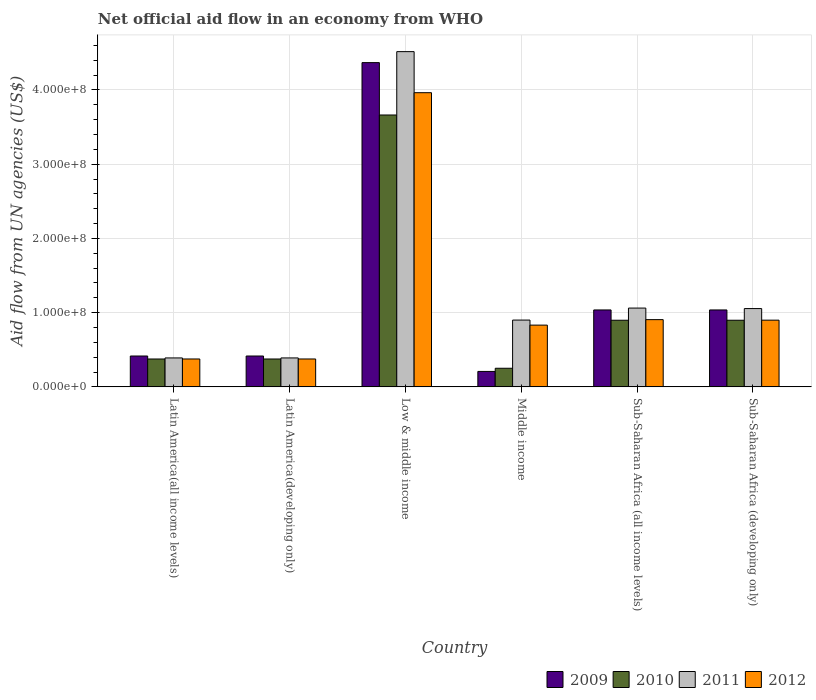Are the number of bars on each tick of the X-axis equal?
Offer a very short reply. Yes. How many bars are there on the 1st tick from the right?
Your answer should be very brief. 4. What is the label of the 1st group of bars from the left?
Ensure brevity in your answer.  Latin America(all income levels). In how many cases, is the number of bars for a given country not equal to the number of legend labels?
Give a very brief answer. 0. What is the net official aid flow in 2009 in Sub-Saharan Africa (developing only)?
Your answer should be very brief. 1.04e+08. Across all countries, what is the maximum net official aid flow in 2011?
Your answer should be compact. 4.52e+08. Across all countries, what is the minimum net official aid flow in 2010?
Keep it short and to the point. 2.51e+07. In which country was the net official aid flow in 2010 maximum?
Provide a succinct answer. Low & middle income. What is the total net official aid flow in 2011 in the graph?
Your response must be concise. 8.31e+08. What is the difference between the net official aid flow in 2012 in Latin America(developing only) and that in Middle income?
Keep it short and to the point. -4.56e+07. What is the difference between the net official aid flow in 2011 in Low & middle income and the net official aid flow in 2009 in Middle income?
Keep it short and to the point. 4.31e+08. What is the average net official aid flow in 2009 per country?
Provide a short and direct response. 1.25e+08. What is the difference between the net official aid flow of/in 2009 and net official aid flow of/in 2012 in Middle income?
Make the answer very short. -6.24e+07. In how many countries, is the net official aid flow in 2011 greater than 340000000 US$?
Offer a very short reply. 1. What is the ratio of the net official aid flow in 2009 in Sub-Saharan Africa (all income levels) to that in Sub-Saharan Africa (developing only)?
Offer a very short reply. 1. Is the net official aid flow in 2009 in Latin America(developing only) less than that in Middle income?
Make the answer very short. No. What is the difference between the highest and the second highest net official aid flow in 2012?
Your response must be concise. 3.06e+08. What is the difference between the highest and the lowest net official aid flow in 2010?
Your answer should be compact. 3.41e+08. Is it the case that in every country, the sum of the net official aid flow in 2011 and net official aid flow in 2012 is greater than the sum of net official aid flow in 2010 and net official aid flow in 2009?
Your answer should be very brief. No. What does the 3rd bar from the right in Low & middle income represents?
Offer a very short reply. 2010. Is it the case that in every country, the sum of the net official aid flow in 2009 and net official aid flow in 2010 is greater than the net official aid flow in 2012?
Offer a very short reply. No. How many countries are there in the graph?
Give a very brief answer. 6. Does the graph contain any zero values?
Your response must be concise. No. Does the graph contain grids?
Offer a very short reply. Yes. How many legend labels are there?
Your answer should be very brief. 4. What is the title of the graph?
Keep it short and to the point. Net official aid flow in an economy from WHO. What is the label or title of the Y-axis?
Your answer should be very brief. Aid flow from UN agencies (US$). What is the Aid flow from UN agencies (US$) in 2009 in Latin America(all income levels)?
Keep it short and to the point. 4.16e+07. What is the Aid flow from UN agencies (US$) in 2010 in Latin America(all income levels)?
Provide a succinct answer. 3.76e+07. What is the Aid flow from UN agencies (US$) in 2011 in Latin America(all income levels)?
Make the answer very short. 3.90e+07. What is the Aid flow from UN agencies (US$) in 2012 in Latin America(all income levels)?
Your answer should be compact. 3.76e+07. What is the Aid flow from UN agencies (US$) in 2009 in Latin America(developing only)?
Keep it short and to the point. 4.16e+07. What is the Aid flow from UN agencies (US$) in 2010 in Latin America(developing only)?
Your response must be concise. 3.76e+07. What is the Aid flow from UN agencies (US$) in 2011 in Latin America(developing only)?
Provide a succinct answer. 3.90e+07. What is the Aid flow from UN agencies (US$) of 2012 in Latin America(developing only)?
Your response must be concise. 3.76e+07. What is the Aid flow from UN agencies (US$) of 2009 in Low & middle income?
Your answer should be very brief. 4.37e+08. What is the Aid flow from UN agencies (US$) of 2010 in Low & middle income?
Offer a terse response. 3.66e+08. What is the Aid flow from UN agencies (US$) of 2011 in Low & middle income?
Give a very brief answer. 4.52e+08. What is the Aid flow from UN agencies (US$) in 2012 in Low & middle income?
Offer a very short reply. 3.96e+08. What is the Aid flow from UN agencies (US$) of 2009 in Middle income?
Ensure brevity in your answer.  2.08e+07. What is the Aid flow from UN agencies (US$) in 2010 in Middle income?
Keep it short and to the point. 2.51e+07. What is the Aid flow from UN agencies (US$) of 2011 in Middle income?
Your response must be concise. 9.00e+07. What is the Aid flow from UN agencies (US$) of 2012 in Middle income?
Offer a terse response. 8.32e+07. What is the Aid flow from UN agencies (US$) in 2009 in Sub-Saharan Africa (all income levels)?
Give a very brief answer. 1.04e+08. What is the Aid flow from UN agencies (US$) in 2010 in Sub-Saharan Africa (all income levels)?
Your answer should be very brief. 8.98e+07. What is the Aid flow from UN agencies (US$) of 2011 in Sub-Saharan Africa (all income levels)?
Make the answer very short. 1.06e+08. What is the Aid flow from UN agencies (US$) in 2012 in Sub-Saharan Africa (all income levels)?
Make the answer very short. 9.06e+07. What is the Aid flow from UN agencies (US$) of 2009 in Sub-Saharan Africa (developing only)?
Give a very brief answer. 1.04e+08. What is the Aid flow from UN agencies (US$) of 2010 in Sub-Saharan Africa (developing only)?
Your answer should be very brief. 8.98e+07. What is the Aid flow from UN agencies (US$) of 2011 in Sub-Saharan Africa (developing only)?
Provide a short and direct response. 1.05e+08. What is the Aid flow from UN agencies (US$) of 2012 in Sub-Saharan Africa (developing only)?
Provide a succinct answer. 8.98e+07. Across all countries, what is the maximum Aid flow from UN agencies (US$) of 2009?
Ensure brevity in your answer.  4.37e+08. Across all countries, what is the maximum Aid flow from UN agencies (US$) of 2010?
Give a very brief answer. 3.66e+08. Across all countries, what is the maximum Aid flow from UN agencies (US$) of 2011?
Make the answer very short. 4.52e+08. Across all countries, what is the maximum Aid flow from UN agencies (US$) in 2012?
Give a very brief answer. 3.96e+08. Across all countries, what is the minimum Aid flow from UN agencies (US$) in 2009?
Your answer should be very brief. 2.08e+07. Across all countries, what is the minimum Aid flow from UN agencies (US$) in 2010?
Give a very brief answer. 2.51e+07. Across all countries, what is the minimum Aid flow from UN agencies (US$) of 2011?
Give a very brief answer. 3.90e+07. Across all countries, what is the minimum Aid flow from UN agencies (US$) of 2012?
Keep it short and to the point. 3.76e+07. What is the total Aid flow from UN agencies (US$) of 2009 in the graph?
Make the answer very short. 7.48e+08. What is the total Aid flow from UN agencies (US$) of 2010 in the graph?
Give a very brief answer. 6.46e+08. What is the total Aid flow from UN agencies (US$) in 2011 in the graph?
Provide a short and direct response. 8.31e+08. What is the total Aid flow from UN agencies (US$) in 2012 in the graph?
Keep it short and to the point. 7.35e+08. What is the difference between the Aid flow from UN agencies (US$) in 2009 in Latin America(all income levels) and that in Latin America(developing only)?
Provide a succinct answer. 0. What is the difference between the Aid flow from UN agencies (US$) in 2010 in Latin America(all income levels) and that in Latin America(developing only)?
Your answer should be compact. 0. What is the difference between the Aid flow from UN agencies (US$) in 2011 in Latin America(all income levels) and that in Latin America(developing only)?
Your answer should be compact. 0. What is the difference between the Aid flow from UN agencies (US$) in 2009 in Latin America(all income levels) and that in Low & middle income?
Your answer should be very brief. -3.95e+08. What is the difference between the Aid flow from UN agencies (US$) in 2010 in Latin America(all income levels) and that in Low & middle income?
Your response must be concise. -3.29e+08. What is the difference between the Aid flow from UN agencies (US$) in 2011 in Latin America(all income levels) and that in Low & middle income?
Provide a short and direct response. -4.13e+08. What is the difference between the Aid flow from UN agencies (US$) of 2012 in Latin America(all income levels) and that in Low & middle income?
Your answer should be compact. -3.59e+08. What is the difference between the Aid flow from UN agencies (US$) in 2009 in Latin America(all income levels) and that in Middle income?
Your answer should be very brief. 2.08e+07. What is the difference between the Aid flow from UN agencies (US$) of 2010 in Latin America(all income levels) and that in Middle income?
Your answer should be very brief. 1.25e+07. What is the difference between the Aid flow from UN agencies (US$) of 2011 in Latin America(all income levels) and that in Middle income?
Offer a terse response. -5.10e+07. What is the difference between the Aid flow from UN agencies (US$) of 2012 in Latin America(all income levels) and that in Middle income?
Ensure brevity in your answer.  -4.56e+07. What is the difference between the Aid flow from UN agencies (US$) of 2009 in Latin America(all income levels) and that in Sub-Saharan Africa (all income levels)?
Offer a terse response. -6.20e+07. What is the difference between the Aid flow from UN agencies (US$) in 2010 in Latin America(all income levels) and that in Sub-Saharan Africa (all income levels)?
Provide a short and direct response. -5.22e+07. What is the difference between the Aid flow from UN agencies (US$) in 2011 in Latin America(all income levels) and that in Sub-Saharan Africa (all income levels)?
Provide a succinct answer. -6.72e+07. What is the difference between the Aid flow from UN agencies (US$) of 2012 in Latin America(all income levels) and that in Sub-Saharan Africa (all income levels)?
Offer a very short reply. -5.30e+07. What is the difference between the Aid flow from UN agencies (US$) in 2009 in Latin America(all income levels) and that in Sub-Saharan Africa (developing only)?
Your answer should be compact. -6.20e+07. What is the difference between the Aid flow from UN agencies (US$) of 2010 in Latin America(all income levels) and that in Sub-Saharan Africa (developing only)?
Give a very brief answer. -5.22e+07. What is the difference between the Aid flow from UN agencies (US$) in 2011 in Latin America(all income levels) and that in Sub-Saharan Africa (developing only)?
Offer a very short reply. -6.65e+07. What is the difference between the Aid flow from UN agencies (US$) of 2012 in Latin America(all income levels) and that in Sub-Saharan Africa (developing only)?
Provide a short and direct response. -5.23e+07. What is the difference between the Aid flow from UN agencies (US$) of 2009 in Latin America(developing only) and that in Low & middle income?
Provide a short and direct response. -3.95e+08. What is the difference between the Aid flow from UN agencies (US$) of 2010 in Latin America(developing only) and that in Low & middle income?
Offer a terse response. -3.29e+08. What is the difference between the Aid flow from UN agencies (US$) of 2011 in Latin America(developing only) and that in Low & middle income?
Give a very brief answer. -4.13e+08. What is the difference between the Aid flow from UN agencies (US$) in 2012 in Latin America(developing only) and that in Low & middle income?
Your answer should be very brief. -3.59e+08. What is the difference between the Aid flow from UN agencies (US$) of 2009 in Latin America(developing only) and that in Middle income?
Keep it short and to the point. 2.08e+07. What is the difference between the Aid flow from UN agencies (US$) in 2010 in Latin America(developing only) and that in Middle income?
Ensure brevity in your answer.  1.25e+07. What is the difference between the Aid flow from UN agencies (US$) in 2011 in Latin America(developing only) and that in Middle income?
Provide a short and direct response. -5.10e+07. What is the difference between the Aid flow from UN agencies (US$) in 2012 in Latin America(developing only) and that in Middle income?
Your answer should be very brief. -4.56e+07. What is the difference between the Aid flow from UN agencies (US$) of 2009 in Latin America(developing only) and that in Sub-Saharan Africa (all income levels)?
Offer a terse response. -6.20e+07. What is the difference between the Aid flow from UN agencies (US$) in 2010 in Latin America(developing only) and that in Sub-Saharan Africa (all income levels)?
Keep it short and to the point. -5.22e+07. What is the difference between the Aid flow from UN agencies (US$) of 2011 in Latin America(developing only) and that in Sub-Saharan Africa (all income levels)?
Give a very brief answer. -6.72e+07. What is the difference between the Aid flow from UN agencies (US$) of 2012 in Latin America(developing only) and that in Sub-Saharan Africa (all income levels)?
Your response must be concise. -5.30e+07. What is the difference between the Aid flow from UN agencies (US$) in 2009 in Latin America(developing only) and that in Sub-Saharan Africa (developing only)?
Provide a succinct answer. -6.20e+07. What is the difference between the Aid flow from UN agencies (US$) in 2010 in Latin America(developing only) and that in Sub-Saharan Africa (developing only)?
Keep it short and to the point. -5.22e+07. What is the difference between the Aid flow from UN agencies (US$) of 2011 in Latin America(developing only) and that in Sub-Saharan Africa (developing only)?
Your answer should be very brief. -6.65e+07. What is the difference between the Aid flow from UN agencies (US$) in 2012 in Latin America(developing only) and that in Sub-Saharan Africa (developing only)?
Make the answer very short. -5.23e+07. What is the difference between the Aid flow from UN agencies (US$) of 2009 in Low & middle income and that in Middle income?
Make the answer very short. 4.16e+08. What is the difference between the Aid flow from UN agencies (US$) of 2010 in Low & middle income and that in Middle income?
Ensure brevity in your answer.  3.41e+08. What is the difference between the Aid flow from UN agencies (US$) of 2011 in Low & middle income and that in Middle income?
Offer a terse response. 3.62e+08. What is the difference between the Aid flow from UN agencies (US$) of 2012 in Low & middle income and that in Middle income?
Give a very brief answer. 3.13e+08. What is the difference between the Aid flow from UN agencies (US$) of 2009 in Low & middle income and that in Sub-Saharan Africa (all income levels)?
Offer a terse response. 3.33e+08. What is the difference between the Aid flow from UN agencies (US$) in 2010 in Low & middle income and that in Sub-Saharan Africa (all income levels)?
Offer a very short reply. 2.76e+08. What is the difference between the Aid flow from UN agencies (US$) in 2011 in Low & middle income and that in Sub-Saharan Africa (all income levels)?
Keep it short and to the point. 3.45e+08. What is the difference between the Aid flow from UN agencies (US$) in 2012 in Low & middle income and that in Sub-Saharan Africa (all income levels)?
Make the answer very short. 3.06e+08. What is the difference between the Aid flow from UN agencies (US$) in 2009 in Low & middle income and that in Sub-Saharan Africa (developing only)?
Keep it short and to the point. 3.33e+08. What is the difference between the Aid flow from UN agencies (US$) in 2010 in Low & middle income and that in Sub-Saharan Africa (developing only)?
Offer a terse response. 2.76e+08. What is the difference between the Aid flow from UN agencies (US$) in 2011 in Low & middle income and that in Sub-Saharan Africa (developing only)?
Provide a succinct answer. 3.46e+08. What is the difference between the Aid flow from UN agencies (US$) in 2012 in Low & middle income and that in Sub-Saharan Africa (developing only)?
Make the answer very short. 3.06e+08. What is the difference between the Aid flow from UN agencies (US$) of 2009 in Middle income and that in Sub-Saharan Africa (all income levels)?
Your response must be concise. -8.28e+07. What is the difference between the Aid flow from UN agencies (US$) in 2010 in Middle income and that in Sub-Saharan Africa (all income levels)?
Your answer should be compact. -6.47e+07. What is the difference between the Aid flow from UN agencies (US$) in 2011 in Middle income and that in Sub-Saharan Africa (all income levels)?
Your response must be concise. -1.62e+07. What is the difference between the Aid flow from UN agencies (US$) of 2012 in Middle income and that in Sub-Saharan Africa (all income levels)?
Your response must be concise. -7.39e+06. What is the difference between the Aid flow from UN agencies (US$) in 2009 in Middle income and that in Sub-Saharan Africa (developing only)?
Ensure brevity in your answer.  -8.28e+07. What is the difference between the Aid flow from UN agencies (US$) of 2010 in Middle income and that in Sub-Saharan Africa (developing only)?
Your response must be concise. -6.47e+07. What is the difference between the Aid flow from UN agencies (US$) of 2011 in Middle income and that in Sub-Saharan Africa (developing only)?
Make the answer very short. -1.55e+07. What is the difference between the Aid flow from UN agencies (US$) of 2012 in Middle income and that in Sub-Saharan Africa (developing only)?
Ensure brevity in your answer.  -6.67e+06. What is the difference between the Aid flow from UN agencies (US$) in 2009 in Sub-Saharan Africa (all income levels) and that in Sub-Saharan Africa (developing only)?
Ensure brevity in your answer.  0. What is the difference between the Aid flow from UN agencies (US$) of 2011 in Sub-Saharan Africa (all income levels) and that in Sub-Saharan Africa (developing only)?
Keep it short and to the point. 6.70e+05. What is the difference between the Aid flow from UN agencies (US$) in 2012 in Sub-Saharan Africa (all income levels) and that in Sub-Saharan Africa (developing only)?
Ensure brevity in your answer.  7.20e+05. What is the difference between the Aid flow from UN agencies (US$) of 2009 in Latin America(all income levels) and the Aid flow from UN agencies (US$) of 2010 in Latin America(developing only)?
Provide a succinct answer. 4.01e+06. What is the difference between the Aid flow from UN agencies (US$) of 2009 in Latin America(all income levels) and the Aid flow from UN agencies (US$) of 2011 in Latin America(developing only)?
Keep it short and to the point. 2.59e+06. What is the difference between the Aid flow from UN agencies (US$) of 2009 in Latin America(all income levels) and the Aid flow from UN agencies (US$) of 2012 in Latin America(developing only)?
Your answer should be compact. 3.99e+06. What is the difference between the Aid flow from UN agencies (US$) of 2010 in Latin America(all income levels) and the Aid flow from UN agencies (US$) of 2011 in Latin America(developing only)?
Give a very brief answer. -1.42e+06. What is the difference between the Aid flow from UN agencies (US$) in 2011 in Latin America(all income levels) and the Aid flow from UN agencies (US$) in 2012 in Latin America(developing only)?
Provide a succinct answer. 1.40e+06. What is the difference between the Aid flow from UN agencies (US$) in 2009 in Latin America(all income levels) and the Aid flow from UN agencies (US$) in 2010 in Low & middle income?
Offer a very short reply. -3.25e+08. What is the difference between the Aid flow from UN agencies (US$) of 2009 in Latin America(all income levels) and the Aid flow from UN agencies (US$) of 2011 in Low & middle income?
Ensure brevity in your answer.  -4.10e+08. What is the difference between the Aid flow from UN agencies (US$) in 2009 in Latin America(all income levels) and the Aid flow from UN agencies (US$) in 2012 in Low & middle income?
Your answer should be very brief. -3.55e+08. What is the difference between the Aid flow from UN agencies (US$) in 2010 in Latin America(all income levels) and the Aid flow from UN agencies (US$) in 2011 in Low & middle income?
Your answer should be very brief. -4.14e+08. What is the difference between the Aid flow from UN agencies (US$) of 2010 in Latin America(all income levels) and the Aid flow from UN agencies (US$) of 2012 in Low & middle income?
Make the answer very short. -3.59e+08. What is the difference between the Aid flow from UN agencies (US$) in 2011 in Latin America(all income levels) and the Aid flow from UN agencies (US$) in 2012 in Low & middle income?
Your answer should be very brief. -3.57e+08. What is the difference between the Aid flow from UN agencies (US$) in 2009 in Latin America(all income levels) and the Aid flow from UN agencies (US$) in 2010 in Middle income?
Provide a succinct answer. 1.65e+07. What is the difference between the Aid flow from UN agencies (US$) of 2009 in Latin America(all income levels) and the Aid flow from UN agencies (US$) of 2011 in Middle income?
Your response must be concise. -4.84e+07. What is the difference between the Aid flow from UN agencies (US$) in 2009 in Latin America(all income levels) and the Aid flow from UN agencies (US$) in 2012 in Middle income?
Your answer should be very brief. -4.16e+07. What is the difference between the Aid flow from UN agencies (US$) of 2010 in Latin America(all income levels) and the Aid flow from UN agencies (US$) of 2011 in Middle income?
Make the answer very short. -5.24e+07. What is the difference between the Aid flow from UN agencies (US$) of 2010 in Latin America(all income levels) and the Aid flow from UN agencies (US$) of 2012 in Middle income?
Make the answer very short. -4.56e+07. What is the difference between the Aid flow from UN agencies (US$) of 2011 in Latin America(all income levels) and the Aid flow from UN agencies (US$) of 2012 in Middle income?
Offer a terse response. -4.42e+07. What is the difference between the Aid flow from UN agencies (US$) of 2009 in Latin America(all income levels) and the Aid flow from UN agencies (US$) of 2010 in Sub-Saharan Africa (all income levels)?
Your answer should be very brief. -4.82e+07. What is the difference between the Aid flow from UN agencies (US$) in 2009 in Latin America(all income levels) and the Aid flow from UN agencies (US$) in 2011 in Sub-Saharan Africa (all income levels)?
Give a very brief answer. -6.46e+07. What is the difference between the Aid flow from UN agencies (US$) in 2009 in Latin America(all income levels) and the Aid flow from UN agencies (US$) in 2012 in Sub-Saharan Africa (all income levels)?
Your answer should be very brief. -4.90e+07. What is the difference between the Aid flow from UN agencies (US$) of 2010 in Latin America(all income levels) and the Aid flow from UN agencies (US$) of 2011 in Sub-Saharan Africa (all income levels)?
Provide a short and direct response. -6.86e+07. What is the difference between the Aid flow from UN agencies (US$) in 2010 in Latin America(all income levels) and the Aid flow from UN agencies (US$) in 2012 in Sub-Saharan Africa (all income levels)?
Provide a short and direct response. -5.30e+07. What is the difference between the Aid flow from UN agencies (US$) of 2011 in Latin America(all income levels) and the Aid flow from UN agencies (US$) of 2012 in Sub-Saharan Africa (all income levels)?
Your response must be concise. -5.16e+07. What is the difference between the Aid flow from UN agencies (US$) of 2009 in Latin America(all income levels) and the Aid flow from UN agencies (US$) of 2010 in Sub-Saharan Africa (developing only)?
Your answer should be compact. -4.82e+07. What is the difference between the Aid flow from UN agencies (US$) of 2009 in Latin America(all income levels) and the Aid flow from UN agencies (US$) of 2011 in Sub-Saharan Africa (developing only)?
Make the answer very short. -6.39e+07. What is the difference between the Aid flow from UN agencies (US$) in 2009 in Latin America(all income levels) and the Aid flow from UN agencies (US$) in 2012 in Sub-Saharan Africa (developing only)?
Ensure brevity in your answer.  -4.83e+07. What is the difference between the Aid flow from UN agencies (US$) of 2010 in Latin America(all income levels) and the Aid flow from UN agencies (US$) of 2011 in Sub-Saharan Africa (developing only)?
Your response must be concise. -6.79e+07. What is the difference between the Aid flow from UN agencies (US$) in 2010 in Latin America(all income levels) and the Aid flow from UN agencies (US$) in 2012 in Sub-Saharan Africa (developing only)?
Your answer should be very brief. -5.23e+07. What is the difference between the Aid flow from UN agencies (US$) in 2011 in Latin America(all income levels) and the Aid flow from UN agencies (US$) in 2012 in Sub-Saharan Africa (developing only)?
Offer a very short reply. -5.09e+07. What is the difference between the Aid flow from UN agencies (US$) in 2009 in Latin America(developing only) and the Aid flow from UN agencies (US$) in 2010 in Low & middle income?
Offer a terse response. -3.25e+08. What is the difference between the Aid flow from UN agencies (US$) in 2009 in Latin America(developing only) and the Aid flow from UN agencies (US$) in 2011 in Low & middle income?
Keep it short and to the point. -4.10e+08. What is the difference between the Aid flow from UN agencies (US$) in 2009 in Latin America(developing only) and the Aid flow from UN agencies (US$) in 2012 in Low & middle income?
Give a very brief answer. -3.55e+08. What is the difference between the Aid flow from UN agencies (US$) in 2010 in Latin America(developing only) and the Aid flow from UN agencies (US$) in 2011 in Low & middle income?
Your response must be concise. -4.14e+08. What is the difference between the Aid flow from UN agencies (US$) in 2010 in Latin America(developing only) and the Aid flow from UN agencies (US$) in 2012 in Low & middle income?
Give a very brief answer. -3.59e+08. What is the difference between the Aid flow from UN agencies (US$) in 2011 in Latin America(developing only) and the Aid flow from UN agencies (US$) in 2012 in Low & middle income?
Offer a very short reply. -3.57e+08. What is the difference between the Aid flow from UN agencies (US$) of 2009 in Latin America(developing only) and the Aid flow from UN agencies (US$) of 2010 in Middle income?
Keep it short and to the point. 1.65e+07. What is the difference between the Aid flow from UN agencies (US$) in 2009 in Latin America(developing only) and the Aid flow from UN agencies (US$) in 2011 in Middle income?
Your response must be concise. -4.84e+07. What is the difference between the Aid flow from UN agencies (US$) of 2009 in Latin America(developing only) and the Aid flow from UN agencies (US$) of 2012 in Middle income?
Your answer should be compact. -4.16e+07. What is the difference between the Aid flow from UN agencies (US$) in 2010 in Latin America(developing only) and the Aid flow from UN agencies (US$) in 2011 in Middle income?
Offer a very short reply. -5.24e+07. What is the difference between the Aid flow from UN agencies (US$) of 2010 in Latin America(developing only) and the Aid flow from UN agencies (US$) of 2012 in Middle income?
Your answer should be compact. -4.56e+07. What is the difference between the Aid flow from UN agencies (US$) of 2011 in Latin America(developing only) and the Aid flow from UN agencies (US$) of 2012 in Middle income?
Your answer should be very brief. -4.42e+07. What is the difference between the Aid flow from UN agencies (US$) in 2009 in Latin America(developing only) and the Aid flow from UN agencies (US$) in 2010 in Sub-Saharan Africa (all income levels)?
Your answer should be compact. -4.82e+07. What is the difference between the Aid flow from UN agencies (US$) in 2009 in Latin America(developing only) and the Aid flow from UN agencies (US$) in 2011 in Sub-Saharan Africa (all income levels)?
Provide a short and direct response. -6.46e+07. What is the difference between the Aid flow from UN agencies (US$) of 2009 in Latin America(developing only) and the Aid flow from UN agencies (US$) of 2012 in Sub-Saharan Africa (all income levels)?
Offer a very short reply. -4.90e+07. What is the difference between the Aid flow from UN agencies (US$) in 2010 in Latin America(developing only) and the Aid flow from UN agencies (US$) in 2011 in Sub-Saharan Africa (all income levels)?
Your response must be concise. -6.86e+07. What is the difference between the Aid flow from UN agencies (US$) in 2010 in Latin America(developing only) and the Aid flow from UN agencies (US$) in 2012 in Sub-Saharan Africa (all income levels)?
Provide a succinct answer. -5.30e+07. What is the difference between the Aid flow from UN agencies (US$) in 2011 in Latin America(developing only) and the Aid flow from UN agencies (US$) in 2012 in Sub-Saharan Africa (all income levels)?
Ensure brevity in your answer.  -5.16e+07. What is the difference between the Aid flow from UN agencies (US$) in 2009 in Latin America(developing only) and the Aid flow from UN agencies (US$) in 2010 in Sub-Saharan Africa (developing only)?
Your answer should be very brief. -4.82e+07. What is the difference between the Aid flow from UN agencies (US$) in 2009 in Latin America(developing only) and the Aid flow from UN agencies (US$) in 2011 in Sub-Saharan Africa (developing only)?
Ensure brevity in your answer.  -6.39e+07. What is the difference between the Aid flow from UN agencies (US$) in 2009 in Latin America(developing only) and the Aid flow from UN agencies (US$) in 2012 in Sub-Saharan Africa (developing only)?
Your response must be concise. -4.83e+07. What is the difference between the Aid flow from UN agencies (US$) of 2010 in Latin America(developing only) and the Aid flow from UN agencies (US$) of 2011 in Sub-Saharan Africa (developing only)?
Offer a very short reply. -6.79e+07. What is the difference between the Aid flow from UN agencies (US$) in 2010 in Latin America(developing only) and the Aid flow from UN agencies (US$) in 2012 in Sub-Saharan Africa (developing only)?
Keep it short and to the point. -5.23e+07. What is the difference between the Aid flow from UN agencies (US$) of 2011 in Latin America(developing only) and the Aid flow from UN agencies (US$) of 2012 in Sub-Saharan Africa (developing only)?
Provide a short and direct response. -5.09e+07. What is the difference between the Aid flow from UN agencies (US$) in 2009 in Low & middle income and the Aid flow from UN agencies (US$) in 2010 in Middle income?
Make the answer very short. 4.12e+08. What is the difference between the Aid flow from UN agencies (US$) in 2009 in Low & middle income and the Aid flow from UN agencies (US$) in 2011 in Middle income?
Your answer should be very brief. 3.47e+08. What is the difference between the Aid flow from UN agencies (US$) of 2009 in Low & middle income and the Aid flow from UN agencies (US$) of 2012 in Middle income?
Keep it short and to the point. 3.54e+08. What is the difference between the Aid flow from UN agencies (US$) in 2010 in Low & middle income and the Aid flow from UN agencies (US$) in 2011 in Middle income?
Keep it short and to the point. 2.76e+08. What is the difference between the Aid flow from UN agencies (US$) in 2010 in Low & middle income and the Aid flow from UN agencies (US$) in 2012 in Middle income?
Offer a terse response. 2.83e+08. What is the difference between the Aid flow from UN agencies (US$) of 2011 in Low & middle income and the Aid flow from UN agencies (US$) of 2012 in Middle income?
Ensure brevity in your answer.  3.68e+08. What is the difference between the Aid flow from UN agencies (US$) in 2009 in Low & middle income and the Aid flow from UN agencies (US$) in 2010 in Sub-Saharan Africa (all income levels)?
Keep it short and to the point. 3.47e+08. What is the difference between the Aid flow from UN agencies (US$) of 2009 in Low & middle income and the Aid flow from UN agencies (US$) of 2011 in Sub-Saharan Africa (all income levels)?
Ensure brevity in your answer.  3.31e+08. What is the difference between the Aid flow from UN agencies (US$) in 2009 in Low & middle income and the Aid flow from UN agencies (US$) in 2012 in Sub-Saharan Africa (all income levels)?
Offer a terse response. 3.46e+08. What is the difference between the Aid flow from UN agencies (US$) of 2010 in Low & middle income and the Aid flow from UN agencies (US$) of 2011 in Sub-Saharan Africa (all income levels)?
Provide a short and direct response. 2.60e+08. What is the difference between the Aid flow from UN agencies (US$) in 2010 in Low & middle income and the Aid flow from UN agencies (US$) in 2012 in Sub-Saharan Africa (all income levels)?
Provide a short and direct response. 2.76e+08. What is the difference between the Aid flow from UN agencies (US$) of 2011 in Low & middle income and the Aid flow from UN agencies (US$) of 2012 in Sub-Saharan Africa (all income levels)?
Offer a terse response. 3.61e+08. What is the difference between the Aid flow from UN agencies (US$) of 2009 in Low & middle income and the Aid flow from UN agencies (US$) of 2010 in Sub-Saharan Africa (developing only)?
Provide a succinct answer. 3.47e+08. What is the difference between the Aid flow from UN agencies (US$) in 2009 in Low & middle income and the Aid flow from UN agencies (US$) in 2011 in Sub-Saharan Africa (developing only)?
Provide a succinct answer. 3.31e+08. What is the difference between the Aid flow from UN agencies (US$) of 2009 in Low & middle income and the Aid flow from UN agencies (US$) of 2012 in Sub-Saharan Africa (developing only)?
Keep it short and to the point. 3.47e+08. What is the difference between the Aid flow from UN agencies (US$) of 2010 in Low & middle income and the Aid flow from UN agencies (US$) of 2011 in Sub-Saharan Africa (developing only)?
Your answer should be very brief. 2.61e+08. What is the difference between the Aid flow from UN agencies (US$) of 2010 in Low & middle income and the Aid flow from UN agencies (US$) of 2012 in Sub-Saharan Africa (developing only)?
Provide a succinct answer. 2.76e+08. What is the difference between the Aid flow from UN agencies (US$) of 2011 in Low & middle income and the Aid flow from UN agencies (US$) of 2012 in Sub-Saharan Africa (developing only)?
Offer a terse response. 3.62e+08. What is the difference between the Aid flow from UN agencies (US$) in 2009 in Middle income and the Aid flow from UN agencies (US$) in 2010 in Sub-Saharan Africa (all income levels)?
Give a very brief answer. -6.90e+07. What is the difference between the Aid flow from UN agencies (US$) in 2009 in Middle income and the Aid flow from UN agencies (US$) in 2011 in Sub-Saharan Africa (all income levels)?
Keep it short and to the point. -8.54e+07. What is the difference between the Aid flow from UN agencies (US$) of 2009 in Middle income and the Aid flow from UN agencies (US$) of 2012 in Sub-Saharan Africa (all income levels)?
Your answer should be very brief. -6.98e+07. What is the difference between the Aid flow from UN agencies (US$) of 2010 in Middle income and the Aid flow from UN agencies (US$) of 2011 in Sub-Saharan Africa (all income levels)?
Your answer should be very brief. -8.11e+07. What is the difference between the Aid flow from UN agencies (US$) in 2010 in Middle income and the Aid flow from UN agencies (US$) in 2012 in Sub-Saharan Africa (all income levels)?
Offer a very short reply. -6.55e+07. What is the difference between the Aid flow from UN agencies (US$) of 2011 in Middle income and the Aid flow from UN agencies (US$) of 2012 in Sub-Saharan Africa (all income levels)?
Your response must be concise. -5.90e+05. What is the difference between the Aid flow from UN agencies (US$) in 2009 in Middle income and the Aid flow from UN agencies (US$) in 2010 in Sub-Saharan Africa (developing only)?
Give a very brief answer. -6.90e+07. What is the difference between the Aid flow from UN agencies (US$) in 2009 in Middle income and the Aid flow from UN agencies (US$) in 2011 in Sub-Saharan Africa (developing only)?
Offer a very short reply. -8.47e+07. What is the difference between the Aid flow from UN agencies (US$) of 2009 in Middle income and the Aid flow from UN agencies (US$) of 2012 in Sub-Saharan Africa (developing only)?
Make the answer very short. -6.90e+07. What is the difference between the Aid flow from UN agencies (US$) of 2010 in Middle income and the Aid flow from UN agencies (US$) of 2011 in Sub-Saharan Africa (developing only)?
Your answer should be compact. -8.04e+07. What is the difference between the Aid flow from UN agencies (US$) of 2010 in Middle income and the Aid flow from UN agencies (US$) of 2012 in Sub-Saharan Africa (developing only)?
Provide a short and direct response. -6.48e+07. What is the difference between the Aid flow from UN agencies (US$) in 2011 in Middle income and the Aid flow from UN agencies (US$) in 2012 in Sub-Saharan Africa (developing only)?
Provide a succinct answer. 1.30e+05. What is the difference between the Aid flow from UN agencies (US$) of 2009 in Sub-Saharan Africa (all income levels) and the Aid flow from UN agencies (US$) of 2010 in Sub-Saharan Africa (developing only)?
Give a very brief answer. 1.39e+07. What is the difference between the Aid flow from UN agencies (US$) in 2009 in Sub-Saharan Africa (all income levels) and the Aid flow from UN agencies (US$) in 2011 in Sub-Saharan Africa (developing only)?
Make the answer very short. -1.86e+06. What is the difference between the Aid flow from UN agencies (US$) in 2009 in Sub-Saharan Africa (all income levels) and the Aid flow from UN agencies (US$) in 2012 in Sub-Saharan Africa (developing only)?
Your response must be concise. 1.38e+07. What is the difference between the Aid flow from UN agencies (US$) in 2010 in Sub-Saharan Africa (all income levels) and the Aid flow from UN agencies (US$) in 2011 in Sub-Saharan Africa (developing only)?
Provide a short and direct response. -1.57e+07. What is the difference between the Aid flow from UN agencies (US$) of 2010 in Sub-Saharan Africa (all income levels) and the Aid flow from UN agencies (US$) of 2012 in Sub-Saharan Africa (developing only)?
Your response must be concise. -9.00e+04. What is the difference between the Aid flow from UN agencies (US$) in 2011 in Sub-Saharan Africa (all income levels) and the Aid flow from UN agencies (US$) in 2012 in Sub-Saharan Africa (developing only)?
Your answer should be very brief. 1.63e+07. What is the average Aid flow from UN agencies (US$) of 2009 per country?
Give a very brief answer. 1.25e+08. What is the average Aid flow from UN agencies (US$) in 2010 per country?
Make the answer very short. 1.08e+08. What is the average Aid flow from UN agencies (US$) in 2011 per country?
Provide a short and direct response. 1.39e+08. What is the average Aid flow from UN agencies (US$) in 2012 per country?
Make the answer very short. 1.23e+08. What is the difference between the Aid flow from UN agencies (US$) in 2009 and Aid flow from UN agencies (US$) in 2010 in Latin America(all income levels)?
Provide a short and direct response. 4.01e+06. What is the difference between the Aid flow from UN agencies (US$) of 2009 and Aid flow from UN agencies (US$) of 2011 in Latin America(all income levels)?
Offer a terse response. 2.59e+06. What is the difference between the Aid flow from UN agencies (US$) of 2009 and Aid flow from UN agencies (US$) of 2012 in Latin America(all income levels)?
Your response must be concise. 3.99e+06. What is the difference between the Aid flow from UN agencies (US$) of 2010 and Aid flow from UN agencies (US$) of 2011 in Latin America(all income levels)?
Offer a terse response. -1.42e+06. What is the difference between the Aid flow from UN agencies (US$) in 2010 and Aid flow from UN agencies (US$) in 2012 in Latin America(all income levels)?
Your answer should be very brief. -2.00e+04. What is the difference between the Aid flow from UN agencies (US$) of 2011 and Aid flow from UN agencies (US$) of 2012 in Latin America(all income levels)?
Offer a terse response. 1.40e+06. What is the difference between the Aid flow from UN agencies (US$) of 2009 and Aid flow from UN agencies (US$) of 2010 in Latin America(developing only)?
Offer a very short reply. 4.01e+06. What is the difference between the Aid flow from UN agencies (US$) of 2009 and Aid flow from UN agencies (US$) of 2011 in Latin America(developing only)?
Keep it short and to the point. 2.59e+06. What is the difference between the Aid flow from UN agencies (US$) of 2009 and Aid flow from UN agencies (US$) of 2012 in Latin America(developing only)?
Keep it short and to the point. 3.99e+06. What is the difference between the Aid flow from UN agencies (US$) in 2010 and Aid flow from UN agencies (US$) in 2011 in Latin America(developing only)?
Ensure brevity in your answer.  -1.42e+06. What is the difference between the Aid flow from UN agencies (US$) in 2010 and Aid flow from UN agencies (US$) in 2012 in Latin America(developing only)?
Make the answer very short. -2.00e+04. What is the difference between the Aid flow from UN agencies (US$) in 2011 and Aid flow from UN agencies (US$) in 2012 in Latin America(developing only)?
Your answer should be compact. 1.40e+06. What is the difference between the Aid flow from UN agencies (US$) of 2009 and Aid flow from UN agencies (US$) of 2010 in Low & middle income?
Your answer should be compact. 7.06e+07. What is the difference between the Aid flow from UN agencies (US$) of 2009 and Aid flow from UN agencies (US$) of 2011 in Low & middle income?
Provide a succinct answer. -1.48e+07. What is the difference between the Aid flow from UN agencies (US$) in 2009 and Aid flow from UN agencies (US$) in 2012 in Low & middle income?
Make the answer very short. 4.05e+07. What is the difference between the Aid flow from UN agencies (US$) in 2010 and Aid flow from UN agencies (US$) in 2011 in Low & middle income?
Provide a succinct answer. -8.54e+07. What is the difference between the Aid flow from UN agencies (US$) in 2010 and Aid flow from UN agencies (US$) in 2012 in Low & middle income?
Provide a short and direct response. -3.00e+07. What is the difference between the Aid flow from UN agencies (US$) in 2011 and Aid flow from UN agencies (US$) in 2012 in Low & middle income?
Your answer should be very brief. 5.53e+07. What is the difference between the Aid flow from UN agencies (US$) of 2009 and Aid flow from UN agencies (US$) of 2010 in Middle income?
Ensure brevity in your answer.  -4.27e+06. What is the difference between the Aid flow from UN agencies (US$) of 2009 and Aid flow from UN agencies (US$) of 2011 in Middle income?
Offer a very short reply. -6.92e+07. What is the difference between the Aid flow from UN agencies (US$) of 2009 and Aid flow from UN agencies (US$) of 2012 in Middle income?
Provide a short and direct response. -6.24e+07. What is the difference between the Aid flow from UN agencies (US$) of 2010 and Aid flow from UN agencies (US$) of 2011 in Middle income?
Keep it short and to the point. -6.49e+07. What is the difference between the Aid flow from UN agencies (US$) of 2010 and Aid flow from UN agencies (US$) of 2012 in Middle income?
Keep it short and to the point. -5.81e+07. What is the difference between the Aid flow from UN agencies (US$) of 2011 and Aid flow from UN agencies (US$) of 2012 in Middle income?
Ensure brevity in your answer.  6.80e+06. What is the difference between the Aid flow from UN agencies (US$) of 2009 and Aid flow from UN agencies (US$) of 2010 in Sub-Saharan Africa (all income levels)?
Your response must be concise. 1.39e+07. What is the difference between the Aid flow from UN agencies (US$) of 2009 and Aid flow from UN agencies (US$) of 2011 in Sub-Saharan Africa (all income levels)?
Your response must be concise. -2.53e+06. What is the difference between the Aid flow from UN agencies (US$) in 2009 and Aid flow from UN agencies (US$) in 2012 in Sub-Saharan Africa (all income levels)?
Provide a short and direct response. 1.30e+07. What is the difference between the Aid flow from UN agencies (US$) in 2010 and Aid flow from UN agencies (US$) in 2011 in Sub-Saharan Africa (all income levels)?
Provide a short and direct response. -1.64e+07. What is the difference between the Aid flow from UN agencies (US$) in 2010 and Aid flow from UN agencies (US$) in 2012 in Sub-Saharan Africa (all income levels)?
Give a very brief answer. -8.10e+05. What is the difference between the Aid flow from UN agencies (US$) in 2011 and Aid flow from UN agencies (US$) in 2012 in Sub-Saharan Africa (all income levels)?
Ensure brevity in your answer.  1.56e+07. What is the difference between the Aid flow from UN agencies (US$) of 2009 and Aid flow from UN agencies (US$) of 2010 in Sub-Saharan Africa (developing only)?
Offer a terse response. 1.39e+07. What is the difference between the Aid flow from UN agencies (US$) in 2009 and Aid flow from UN agencies (US$) in 2011 in Sub-Saharan Africa (developing only)?
Keep it short and to the point. -1.86e+06. What is the difference between the Aid flow from UN agencies (US$) of 2009 and Aid flow from UN agencies (US$) of 2012 in Sub-Saharan Africa (developing only)?
Your response must be concise. 1.38e+07. What is the difference between the Aid flow from UN agencies (US$) in 2010 and Aid flow from UN agencies (US$) in 2011 in Sub-Saharan Africa (developing only)?
Your answer should be very brief. -1.57e+07. What is the difference between the Aid flow from UN agencies (US$) of 2011 and Aid flow from UN agencies (US$) of 2012 in Sub-Saharan Africa (developing only)?
Provide a succinct answer. 1.56e+07. What is the ratio of the Aid flow from UN agencies (US$) of 2010 in Latin America(all income levels) to that in Latin America(developing only)?
Your response must be concise. 1. What is the ratio of the Aid flow from UN agencies (US$) in 2011 in Latin America(all income levels) to that in Latin America(developing only)?
Your answer should be compact. 1. What is the ratio of the Aid flow from UN agencies (US$) of 2012 in Latin America(all income levels) to that in Latin America(developing only)?
Ensure brevity in your answer.  1. What is the ratio of the Aid flow from UN agencies (US$) in 2009 in Latin America(all income levels) to that in Low & middle income?
Your response must be concise. 0.1. What is the ratio of the Aid flow from UN agencies (US$) in 2010 in Latin America(all income levels) to that in Low & middle income?
Provide a succinct answer. 0.1. What is the ratio of the Aid flow from UN agencies (US$) in 2011 in Latin America(all income levels) to that in Low & middle income?
Provide a succinct answer. 0.09. What is the ratio of the Aid flow from UN agencies (US$) in 2012 in Latin America(all income levels) to that in Low & middle income?
Your answer should be very brief. 0.09. What is the ratio of the Aid flow from UN agencies (US$) in 2009 in Latin America(all income levels) to that in Middle income?
Provide a succinct answer. 2. What is the ratio of the Aid flow from UN agencies (US$) in 2010 in Latin America(all income levels) to that in Middle income?
Ensure brevity in your answer.  1.5. What is the ratio of the Aid flow from UN agencies (US$) of 2011 in Latin America(all income levels) to that in Middle income?
Ensure brevity in your answer.  0.43. What is the ratio of the Aid flow from UN agencies (US$) in 2012 in Latin America(all income levels) to that in Middle income?
Provide a succinct answer. 0.45. What is the ratio of the Aid flow from UN agencies (US$) in 2009 in Latin America(all income levels) to that in Sub-Saharan Africa (all income levels)?
Keep it short and to the point. 0.4. What is the ratio of the Aid flow from UN agencies (US$) in 2010 in Latin America(all income levels) to that in Sub-Saharan Africa (all income levels)?
Keep it short and to the point. 0.42. What is the ratio of the Aid flow from UN agencies (US$) in 2011 in Latin America(all income levels) to that in Sub-Saharan Africa (all income levels)?
Give a very brief answer. 0.37. What is the ratio of the Aid flow from UN agencies (US$) of 2012 in Latin America(all income levels) to that in Sub-Saharan Africa (all income levels)?
Offer a very short reply. 0.41. What is the ratio of the Aid flow from UN agencies (US$) in 2009 in Latin America(all income levels) to that in Sub-Saharan Africa (developing only)?
Your response must be concise. 0.4. What is the ratio of the Aid flow from UN agencies (US$) in 2010 in Latin America(all income levels) to that in Sub-Saharan Africa (developing only)?
Your answer should be compact. 0.42. What is the ratio of the Aid flow from UN agencies (US$) in 2011 in Latin America(all income levels) to that in Sub-Saharan Africa (developing only)?
Offer a very short reply. 0.37. What is the ratio of the Aid flow from UN agencies (US$) in 2012 in Latin America(all income levels) to that in Sub-Saharan Africa (developing only)?
Provide a short and direct response. 0.42. What is the ratio of the Aid flow from UN agencies (US$) in 2009 in Latin America(developing only) to that in Low & middle income?
Ensure brevity in your answer.  0.1. What is the ratio of the Aid flow from UN agencies (US$) in 2010 in Latin America(developing only) to that in Low & middle income?
Offer a terse response. 0.1. What is the ratio of the Aid flow from UN agencies (US$) in 2011 in Latin America(developing only) to that in Low & middle income?
Your response must be concise. 0.09. What is the ratio of the Aid flow from UN agencies (US$) in 2012 in Latin America(developing only) to that in Low & middle income?
Give a very brief answer. 0.09. What is the ratio of the Aid flow from UN agencies (US$) of 2009 in Latin America(developing only) to that in Middle income?
Ensure brevity in your answer.  2. What is the ratio of the Aid flow from UN agencies (US$) of 2010 in Latin America(developing only) to that in Middle income?
Your answer should be very brief. 1.5. What is the ratio of the Aid flow from UN agencies (US$) in 2011 in Latin America(developing only) to that in Middle income?
Offer a terse response. 0.43. What is the ratio of the Aid flow from UN agencies (US$) of 2012 in Latin America(developing only) to that in Middle income?
Your response must be concise. 0.45. What is the ratio of the Aid flow from UN agencies (US$) in 2009 in Latin America(developing only) to that in Sub-Saharan Africa (all income levels)?
Offer a very short reply. 0.4. What is the ratio of the Aid flow from UN agencies (US$) of 2010 in Latin America(developing only) to that in Sub-Saharan Africa (all income levels)?
Ensure brevity in your answer.  0.42. What is the ratio of the Aid flow from UN agencies (US$) in 2011 in Latin America(developing only) to that in Sub-Saharan Africa (all income levels)?
Make the answer very short. 0.37. What is the ratio of the Aid flow from UN agencies (US$) of 2012 in Latin America(developing only) to that in Sub-Saharan Africa (all income levels)?
Offer a terse response. 0.41. What is the ratio of the Aid flow from UN agencies (US$) of 2009 in Latin America(developing only) to that in Sub-Saharan Africa (developing only)?
Make the answer very short. 0.4. What is the ratio of the Aid flow from UN agencies (US$) in 2010 in Latin America(developing only) to that in Sub-Saharan Africa (developing only)?
Provide a short and direct response. 0.42. What is the ratio of the Aid flow from UN agencies (US$) in 2011 in Latin America(developing only) to that in Sub-Saharan Africa (developing only)?
Provide a short and direct response. 0.37. What is the ratio of the Aid flow from UN agencies (US$) of 2012 in Latin America(developing only) to that in Sub-Saharan Africa (developing only)?
Offer a very short reply. 0.42. What is the ratio of the Aid flow from UN agencies (US$) in 2009 in Low & middle income to that in Middle income?
Keep it short and to the point. 21. What is the ratio of the Aid flow from UN agencies (US$) of 2010 in Low & middle income to that in Middle income?
Provide a short and direct response. 14.61. What is the ratio of the Aid flow from UN agencies (US$) in 2011 in Low & middle income to that in Middle income?
Give a very brief answer. 5.02. What is the ratio of the Aid flow from UN agencies (US$) of 2012 in Low & middle income to that in Middle income?
Make the answer very short. 4.76. What is the ratio of the Aid flow from UN agencies (US$) in 2009 in Low & middle income to that in Sub-Saharan Africa (all income levels)?
Give a very brief answer. 4.22. What is the ratio of the Aid flow from UN agencies (US$) in 2010 in Low & middle income to that in Sub-Saharan Africa (all income levels)?
Offer a very short reply. 4.08. What is the ratio of the Aid flow from UN agencies (US$) in 2011 in Low & middle income to that in Sub-Saharan Africa (all income levels)?
Your response must be concise. 4.25. What is the ratio of the Aid flow from UN agencies (US$) of 2012 in Low & middle income to that in Sub-Saharan Africa (all income levels)?
Your answer should be very brief. 4.38. What is the ratio of the Aid flow from UN agencies (US$) of 2009 in Low & middle income to that in Sub-Saharan Africa (developing only)?
Offer a terse response. 4.22. What is the ratio of the Aid flow from UN agencies (US$) in 2010 in Low & middle income to that in Sub-Saharan Africa (developing only)?
Keep it short and to the point. 4.08. What is the ratio of the Aid flow from UN agencies (US$) in 2011 in Low & middle income to that in Sub-Saharan Africa (developing only)?
Your response must be concise. 4.28. What is the ratio of the Aid flow from UN agencies (US$) of 2012 in Low & middle income to that in Sub-Saharan Africa (developing only)?
Your response must be concise. 4.41. What is the ratio of the Aid flow from UN agencies (US$) of 2009 in Middle income to that in Sub-Saharan Africa (all income levels)?
Keep it short and to the point. 0.2. What is the ratio of the Aid flow from UN agencies (US$) in 2010 in Middle income to that in Sub-Saharan Africa (all income levels)?
Provide a succinct answer. 0.28. What is the ratio of the Aid flow from UN agencies (US$) in 2011 in Middle income to that in Sub-Saharan Africa (all income levels)?
Ensure brevity in your answer.  0.85. What is the ratio of the Aid flow from UN agencies (US$) in 2012 in Middle income to that in Sub-Saharan Africa (all income levels)?
Give a very brief answer. 0.92. What is the ratio of the Aid flow from UN agencies (US$) in 2009 in Middle income to that in Sub-Saharan Africa (developing only)?
Your response must be concise. 0.2. What is the ratio of the Aid flow from UN agencies (US$) of 2010 in Middle income to that in Sub-Saharan Africa (developing only)?
Provide a succinct answer. 0.28. What is the ratio of the Aid flow from UN agencies (US$) in 2011 in Middle income to that in Sub-Saharan Africa (developing only)?
Ensure brevity in your answer.  0.85. What is the ratio of the Aid flow from UN agencies (US$) of 2012 in Middle income to that in Sub-Saharan Africa (developing only)?
Keep it short and to the point. 0.93. What is the ratio of the Aid flow from UN agencies (US$) of 2009 in Sub-Saharan Africa (all income levels) to that in Sub-Saharan Africa (developing only)?
Your answer should be very brief. 1. What is the ratio of the Aid flow from UN agencies (US$) in 2010 in Sub-Saharan Africa (all income levels) to that in Sub-Saharan Africa (developing only)?
Give a very brief answer. 1. What is the ratio of the Aid flow from UN agencies (US$) in 2011 in Sub-Saharan Africa (all income levels) to that in Sub-Saharan Africa (developing only)?
Your response must be concise. 1.01. What is the difference between the highest and the second highest Aid flow from UN agencies (US$) in 2009?
Ensure brevity in your answer.  3.33e+08. What is the difference between the highest and the second highest Aid flow from UN agencies (US$) in 2010?
Make the answer very short. 2.76e+08. What is the difference between the highest and the second highest Aid flow from UN agencies (US$) in 2011?
Your answer should be very brief. 3.45e+08. What is the difference between the highest and the second highest Aid flow from UN agencies (US$) of 2012?
Offer a very short reply. 3.06e+08. What is the difference between the highest and the lowest Aid flow from UN agencies (US$) in 2009?
Provide a succinct answer. 4.16e+08. What is the difference between the highest and the lowest Aid flow from UN agencies (US$) of 2010?
Make the answer very short. 3.41e+08. What is the difference between the highest and the lowest Aid flow from UN agencies (US$) of 2011?
Provide a short and direct response. 4.13e+08. What is the difference between the highest and the lowest Aid flow from UN agencies (US$) in 2012?
Provide a short and direct response. 3.59e+08. 